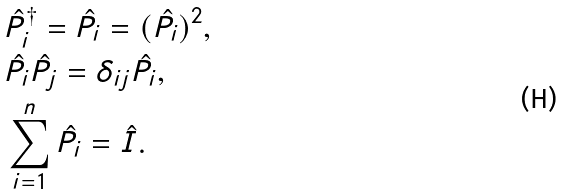Convert formula to latex. <formula><loc_0><loc_0><loc_500><loc_500>& \hat { P } _ { i } ^ { \dagger } = \hat { P } _ { i } = ( \hat { P } _ { i } ) ^ { 2 } , \\ & \hat { P } _ { i } \hat { P } _ { j } = \delta _ { i j } \hat { P } _ { i } , \\ & \sum _ { i = 1 } ^ { n } \hat { P } _ { i } = \hat { I } .</formula> 